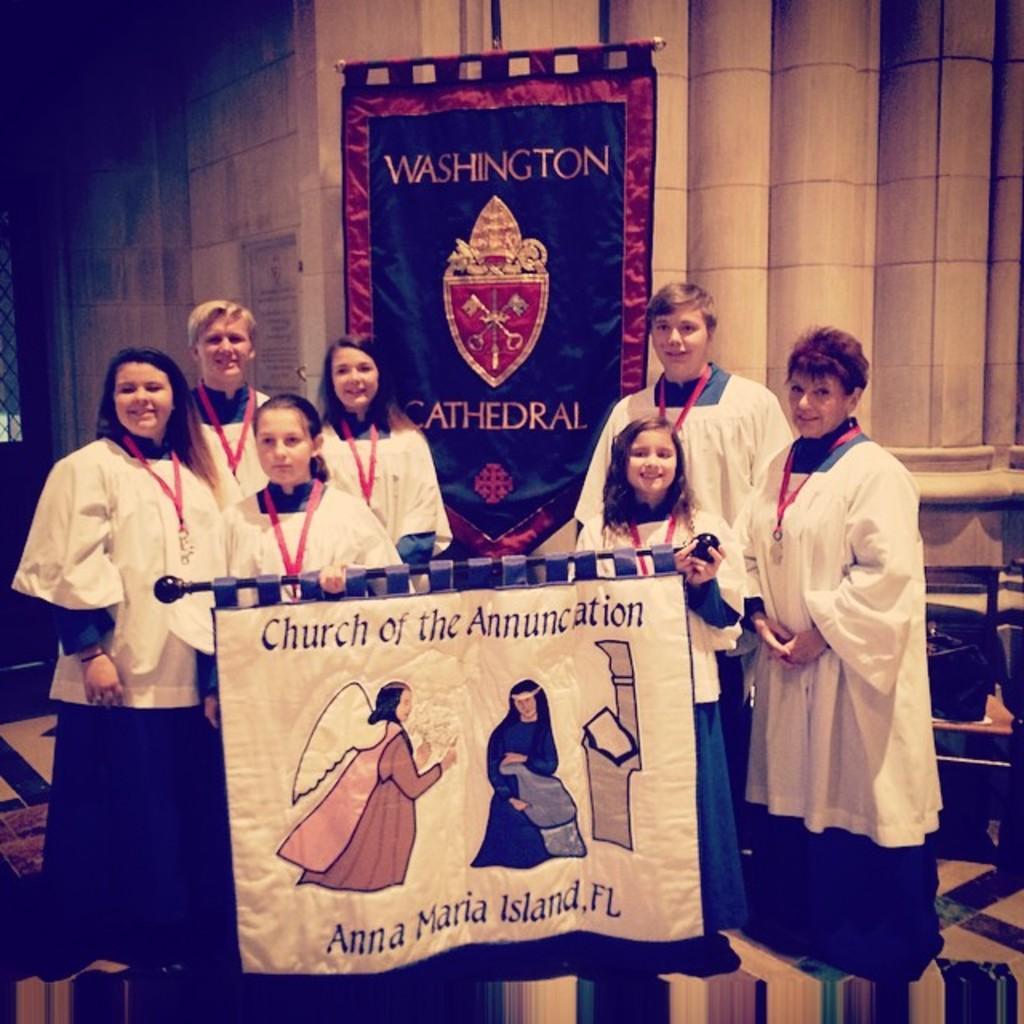Could you give a brief overview of what you see in this image? Here in this picture we can see a group of people standing on the floor over there, as we can see all of them are wearing same type of clothes on them and the children in the middle are holding a cloth in their hands and all of them are smiling and behind them we can see a cloth hanging over there and we can also see pillars of the building over there. 